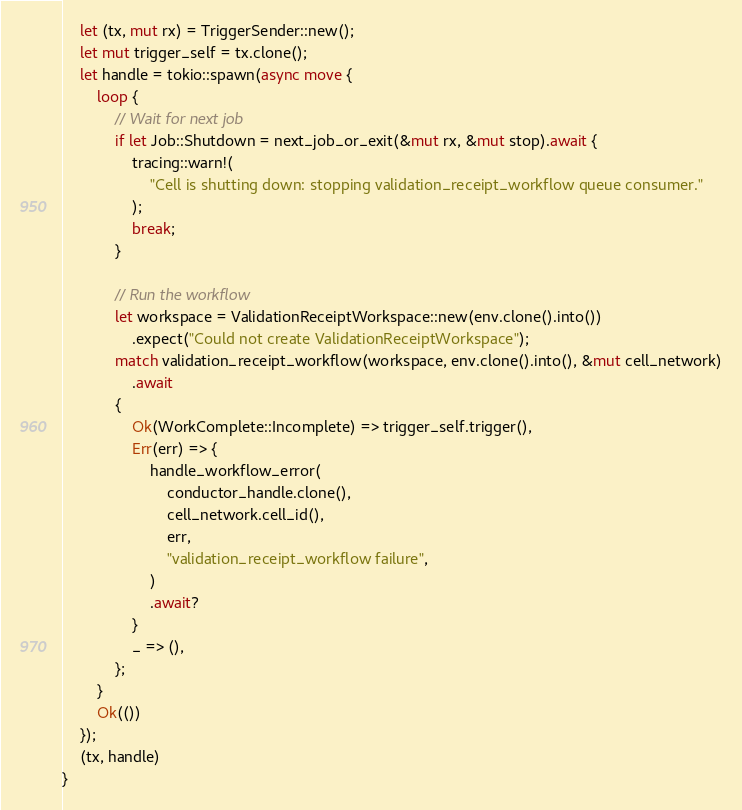<code> <loc_0><loc_0><loc_500><loc_500><_Rust_>    let (tx, mut rx) = TriggerSender::new();
    let mut trigger_self = tx.clone();
    let handle = tokio::spawn(async move {
        loop {
            // Wait for next job
            if let Job::Shutdown = next_job_or_exit(&mut rx, &mut stop).await {
                tracing::warn!(
                    "Cell is shutting down: stopping validation_receipt_workflow queue consumer."
                );
                break;
            }

            // Run the workflow
            let workspace = ValidationReceiptWorkspace::new(env.clone().into())
                .expect("Could not create ValidationReceiptWorkspace");
            match validation_receipt_workflow(workspace, env.clone().into(), &mut cell_network)
                .await
            {
                Ok(WorkComplete::Incomplete) => trigger_self.trigger(),
                Err(err) => {
                    handle_workflow_error(
                        conductor_handle.clone(),
                        cell_network.cell_id(),
                        err,
                        "validation_receipt_workflow failure",
                    )
                    .await?
                }
                _ => (),
            };
        }
        Ok(())
    });
    (tx, handle)
}
</code> 